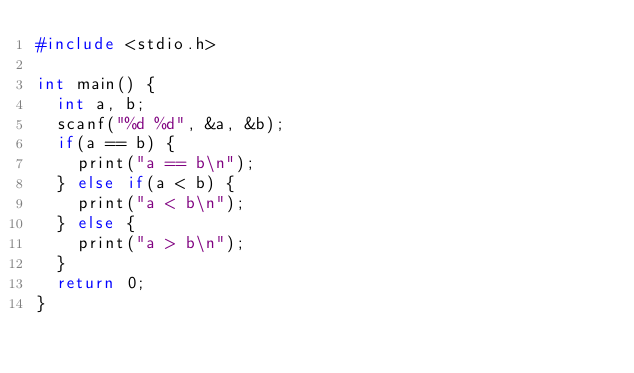<code> <loc_0><loc_0><loc_500><loc_500><_C++_>#include <stdio.h>

int main() {
  int a, b;
  scanf("%d %d", &a, &b);
  if(a == b) {
    print("a == b\n");
  } else if(a < b) {
    print("a < b\n");
  } else {
    print("a > b\n");
  }
  return 0;
}</code> 